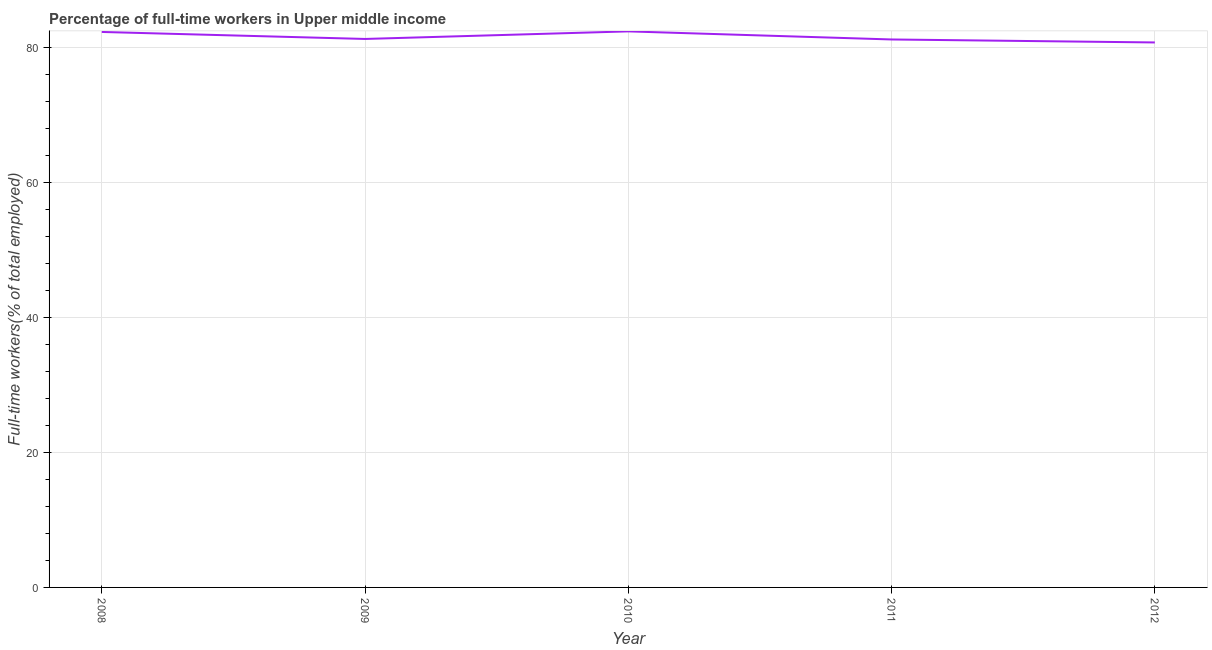What is the percentage of full-time workers in 2008?
Ensure brevity in your answer.  82.24. Across all years, what is the maximum percentage of full-time workers?
Your answer should be very brief. 82.33. Across all years, what is the minimum percentage of full-time workers?
Make the answer very short. 80.69. In which year was the percentage of full-time workers maximum?
Make the answer very short. 2010. What is the sum of the percentage of full-time workers?
Make the answer very short. 407.6. What is the difference between the percentage of full-time workers in 2010 and 2011?
Your response must be concise. 1.2. What is the average percentage of full-time workers per year?
Make the answer very short. 81.52. What is the median percentage of full-time workers?
Provide a short and direct response. 81.21. In how many years, is the percentage of full-time workers greater than 52 %?
Your response must be concise. 5. Do a majority of the years between 2010 and 2012 (inclusive) have percentage of full-time workers greater than 52 %?
Your answer should be compact. Yes. What is the ratio of the percentage of full-time workers in 2009 to that in 2012?
Your answer should be compact. 1.01. Is the percentage of full-time workers in 2008 less than that in 2011?
Give a very brief answer. No. Is the difference between the percentage of full-time workers in 2008 and 2012 greater than the difference between any two years?
Provide a succinct answer. No. What is the difference between the highest and the second highest percentage of full-time workers?
Provide a short and direct response. 0.08. Is the sum of the percentage of full-time workers in 2010 and 2011 greater than the maximum percentage of full-time workers across all years?
Offer a terse response. Yes. What is the difference between the highest and the lowest percentage of full-time workers?
Give a very brief answer. 1.64. Does the percentage of full-time workers monotonically increase over the years?
Your answer should be very brief. No. How many lines are there?
Keep it short and to the point. 1. What is the difference between two consecutive major ticks on the Y-axis?
Offer a very short reply. 20. What is the title of the graph?
Keep it short and to the point. Percentage of full-time workers in Upper middle income. What is the label or title of the X-axis?
Make the answer very short. Year. What is the label or title of the Y-axis?
Make the answer very short. Full-time workers(% of total employed). What is the Full-time workers(% of total employed) in 2008?
Keep it short and to the point. 82.24. What is the Full-time workers(% of total employed) in 2009?
Make the answer very short. 81.21. What is the Full-time workers(% of total employed) in 2010?
Ensure brevity in your answer.  82.33. What is the Full-time workers(% of total employed) of 2011?
Provide a succinct answer. 81.13. What is the Full-time workers(% of total employed) in 2012?
Keep it short and to the point. 80.69. What is the difference between the Full-time workers(% of total employed) in 2008 and 2009?
Your answer should be compact. 1.04. What is the difference between the Full-time workers(% of total employed) in 2008 and 2010?
Provide a succinct answer. -0.08. What is the difference between the Full-time workers(% of total employed) in 2008 and 2011?
Your response must be concise. 1.11. What is the difference between the Full-time workers(% of total employed) in 2008 and 2012?
Your answer should be very brief. 1.56. What is the difference between the Full-time workers(% of total employed) in 2009 and 2010?
Offer a terse response. -1.12. What is the difference between the Full-time workers(% of total employed) in 2009 and 2011?
Your answer should be compact. 0.07. What is the difference between the Full-time workers(% of total employed) in 2009 and 2012?
Your answer should be very brief. 0.52. What is the difference between the Full-time workers(% of total employed) in 2010 and 2011?
Keep it short and to the point. 1.2. What is the difference between the Full-time workers(% of total employed) in 2010 and 2012?
Make the answer very short. 1.64. What is the difference between the Full-time workers(% of total employed) in 2011 and 2012?
Provide a short and direct response. 0.44. What is the ratio of the Full-time workers(% of total employed) in 2008 to that in 2010?
Provide a succinct answer. 1. What is the ratio of the Full-time workers(% of total employed) in 2008 to that in 2011?
Ensure brevity in your answer.  1.01. What is the ratio of the Full-time workers(% of total employed) in 2010 to that in 2012?
Offer a terse response. 1.02. 